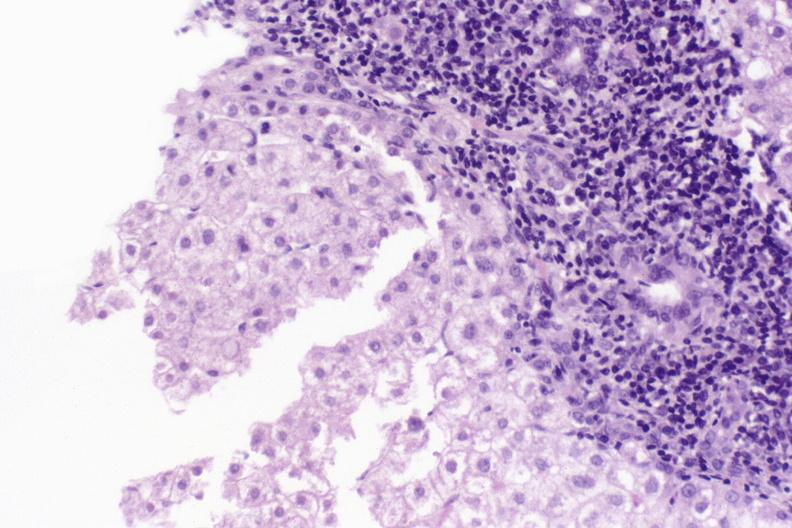does this image show primary biliary cirrhosis?
Answer the question using a single word or phrase. Yes 